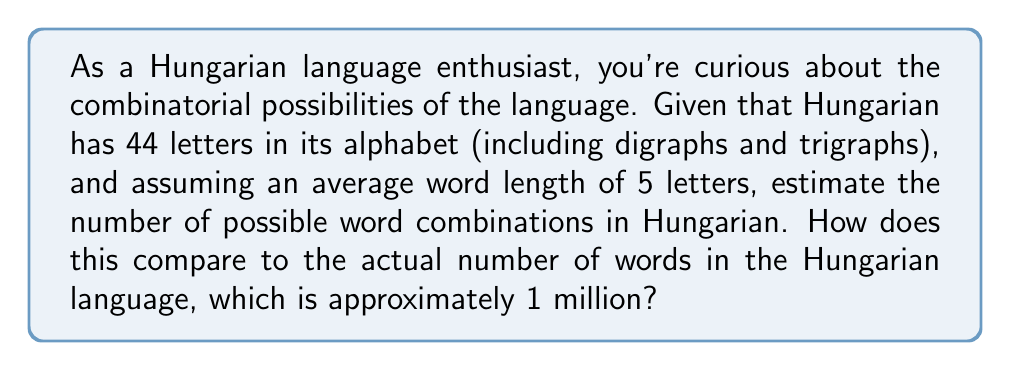Can you solve this math problem? To estimate the number of possible word combinations in Hungarian, we'll use the principles of combinatorial mathematics. Let's break this down step-by-step:

1) First, we need to calculate the number of possible 5-letter combinations using the Hungarian alphabet:

   $$44^5 = 44 \times 44 \times 44 \times 44 \times 44 = 184,528,125$$

   This is because for each of the 5 positions, we have 44 choices.

2) However, this number includes combinations that aren't actual words. In combinatorial linguistics, it's often estimated that only about 1% of possible letter combinations form actual words in a language.

3) So, we can estimate the number of potential words as:

   $$184,528,125 \times 0.01 = 1,845,281$$

4) To compare this to the actual number of words in Hungarian:

   $$\frac{1,845,281}{1,000,000} \approx 1.85$$

This means our estimate is about 1.85 times the actual number of words in Hungarian.

5) The difference can be explained by several factors:
   - Not all words are exactly 5 letters long
   - Some letter combinations are more common than others
   - Language evolution and borrowing create words that might not fit typical combinatorial patterns

This estimate demonstrates the vast potential for word creation in Hungarian, while also showing how languages use only a fraction of possible combinations to create meaningful words.
Answer: The estimated number of possible 5-letter word combinations in Hungarian is approximately 1,845,281, which is about 1.85 times the actual number of words in the Hungarian language. 